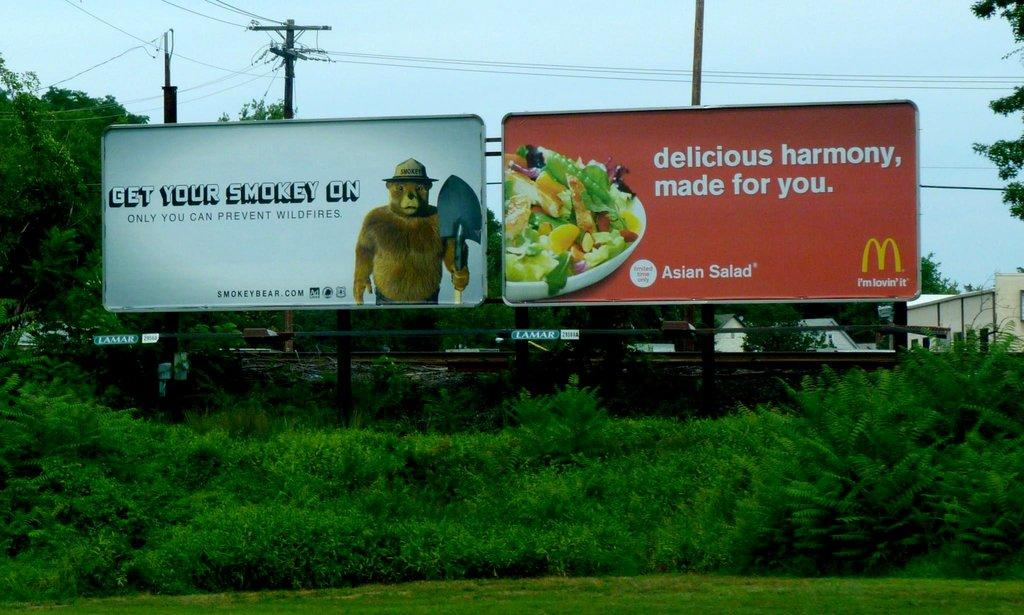Provide a one-sentence caption for the provided image. A pair of billboard signs one of them for McDonalds. 